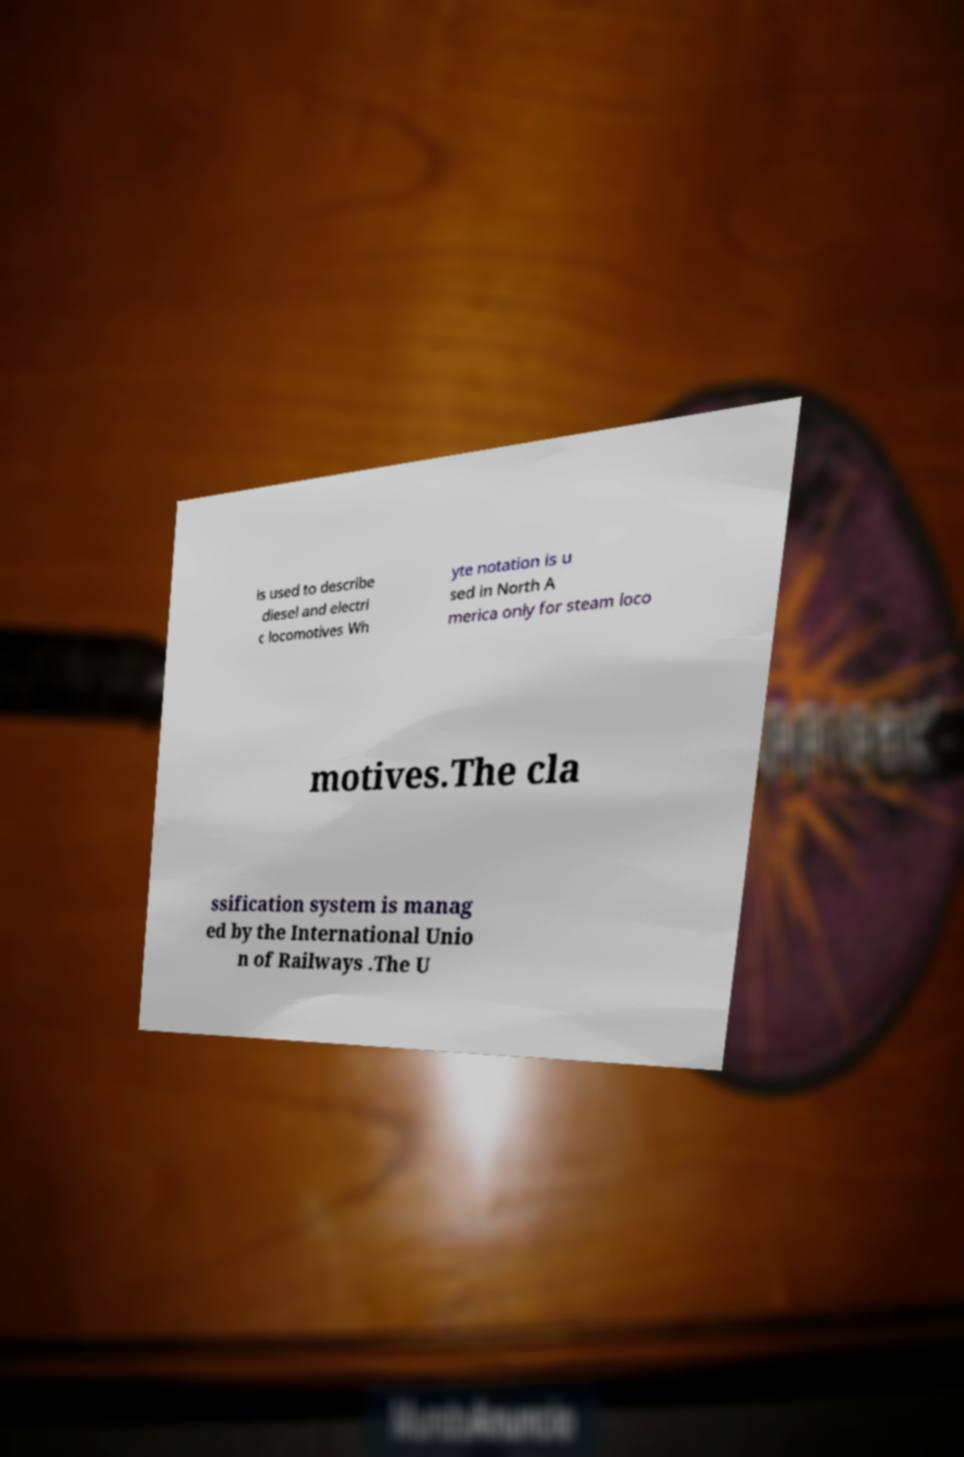Could you extract and type out the text from this image? is used to describe diesel and electri c locomotives Wh yte notation is u sed in North A merica only for steam loco motives.The cla ssification system is manag ed by the International Unio n of Railways .The U 